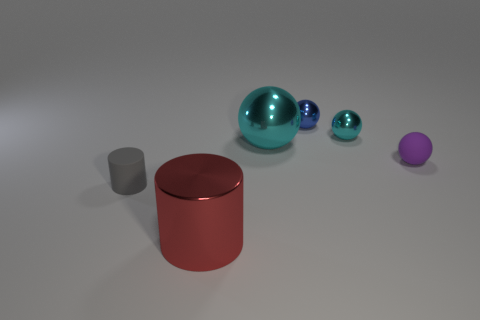Add 1 large red cylinders. How many objects exist? 7 Subtract all blue spheres. How many spheres are left? 3 Subtract 2 balls. How many balls are left? 2 Subtract all blue spheres. How many spheres are left? 3 Subtract 0 red balls. How many objects are left? 6 Subtract all cylinders. How many objects are left? 4 Subtract all cyan cylinders. Subtract all yellow balls. How many cylinders are left? 2 Subtract all purple cubes. How many cyan cylinders are left? 0 Subtract all matte things. Subtract all tiny cyan metallic spheres. How many objects are left? 3 Add 2 purple spheres. How many purple spheres are left? 3 